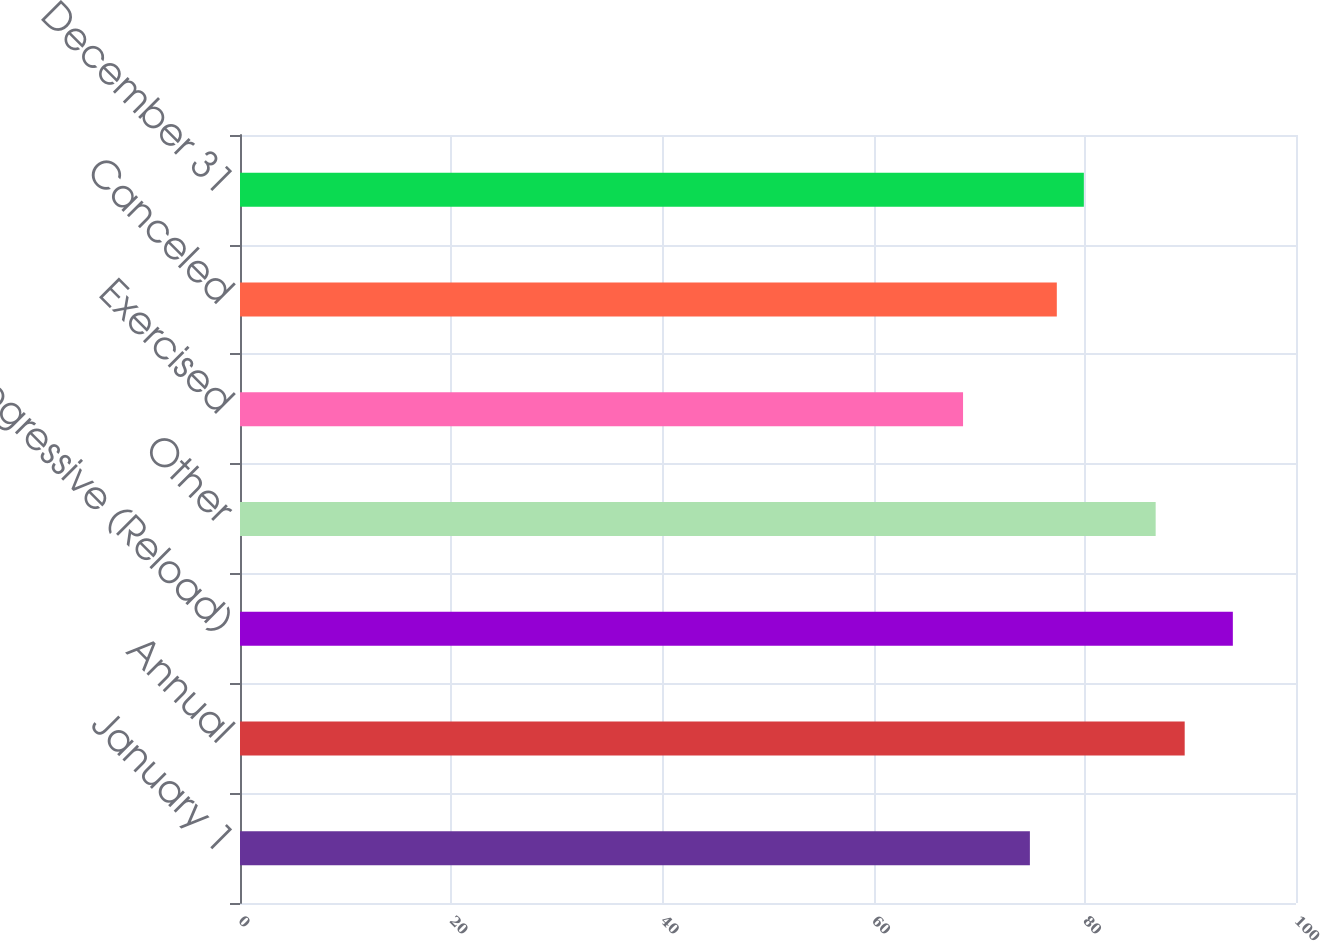Convert chart. <chart><loc_0><loc_0><loc_500><loc_500><bar_chart><fcel>January 1<fcel>Annual<fcel>Progressive (Reload)<fcel>Other<fcel>Exercised<fcel>Canceled<fcel>December 31<nl><fcel>74.8<fcel>89.46<fcel>94.02<fcel>86.71<fcel>68.47<fcel>77.35<fcel>79.91<nl></chart> 